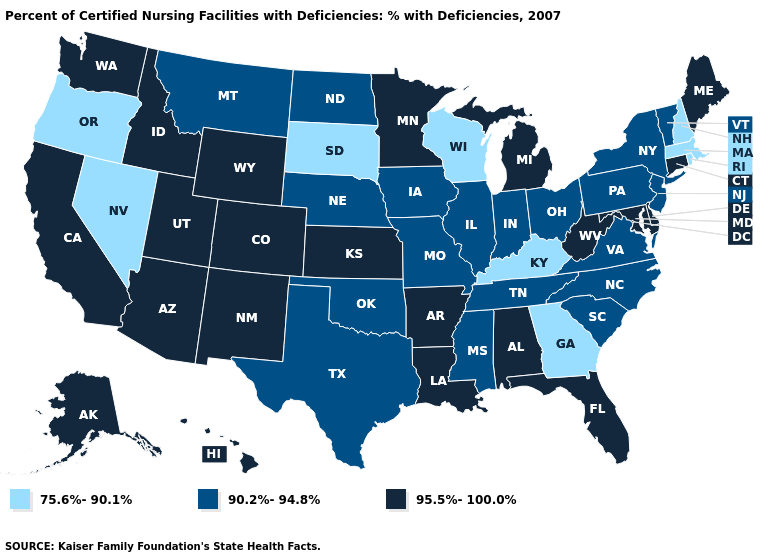What is the value of Indiana?
Short answer required. 90.2%-94.8%. What is the value of Wisconsin?
Answer briefly. 75.6%-90.1%. Which states hav the highest value in the South?
Concise answer only. Alabama, Arkansas, Delaware, Florida, Louisiana, Maryland, West Virginia. What is the lowest value in states that border Louisiana?
Be succinct. 90.2%-94.8%. Does the first symbol in the legend represent the smallest category?
Be succinct. Yes. What is the lowest value in the South?
Be succinct. 75.6%-90.1%. Does Oregon have the lowest value in the USA?
Keep it brief. Yes. Is the legend a continuous bar?
Keep it brief. No. Which states have the lowest value in the USA?
Keep it brief. Georgia, Kentucky, Massachusetts, Nevada, New Hampshire, Oregon, Rhode Island, South Dakota, Wisconsin. What is the value of Indiana?
Quick response, please. 90.2%-94.8%. Is the legend a continuous bar?
Give a very brief answer. No. Name the states that have a value in the range 95.5%-100.0%?
Keep it brief. Alabama, Alaska, Arizona, Arkansas, California, Colorado, Connecticut, Delaware, Florida, Hawaii, Idaho, Kansas, Louisiana, Maine, Maryland, Michigan, Minnesota, New Mexico, Utah, Washington, West Virginia, Wyoming. What is the highest value in states that border California?
Concise answer only. 95.5%-100.0%. Is the legend a continuous bar?
Write a very short answer. No. Which states have the lowest value in the USA?
Answer briefly. Georgia, Kentucky, Massachusetts, Nevada, New Hampshire, Oregon, Rhode Island, South Dakota, Wisconsin. 